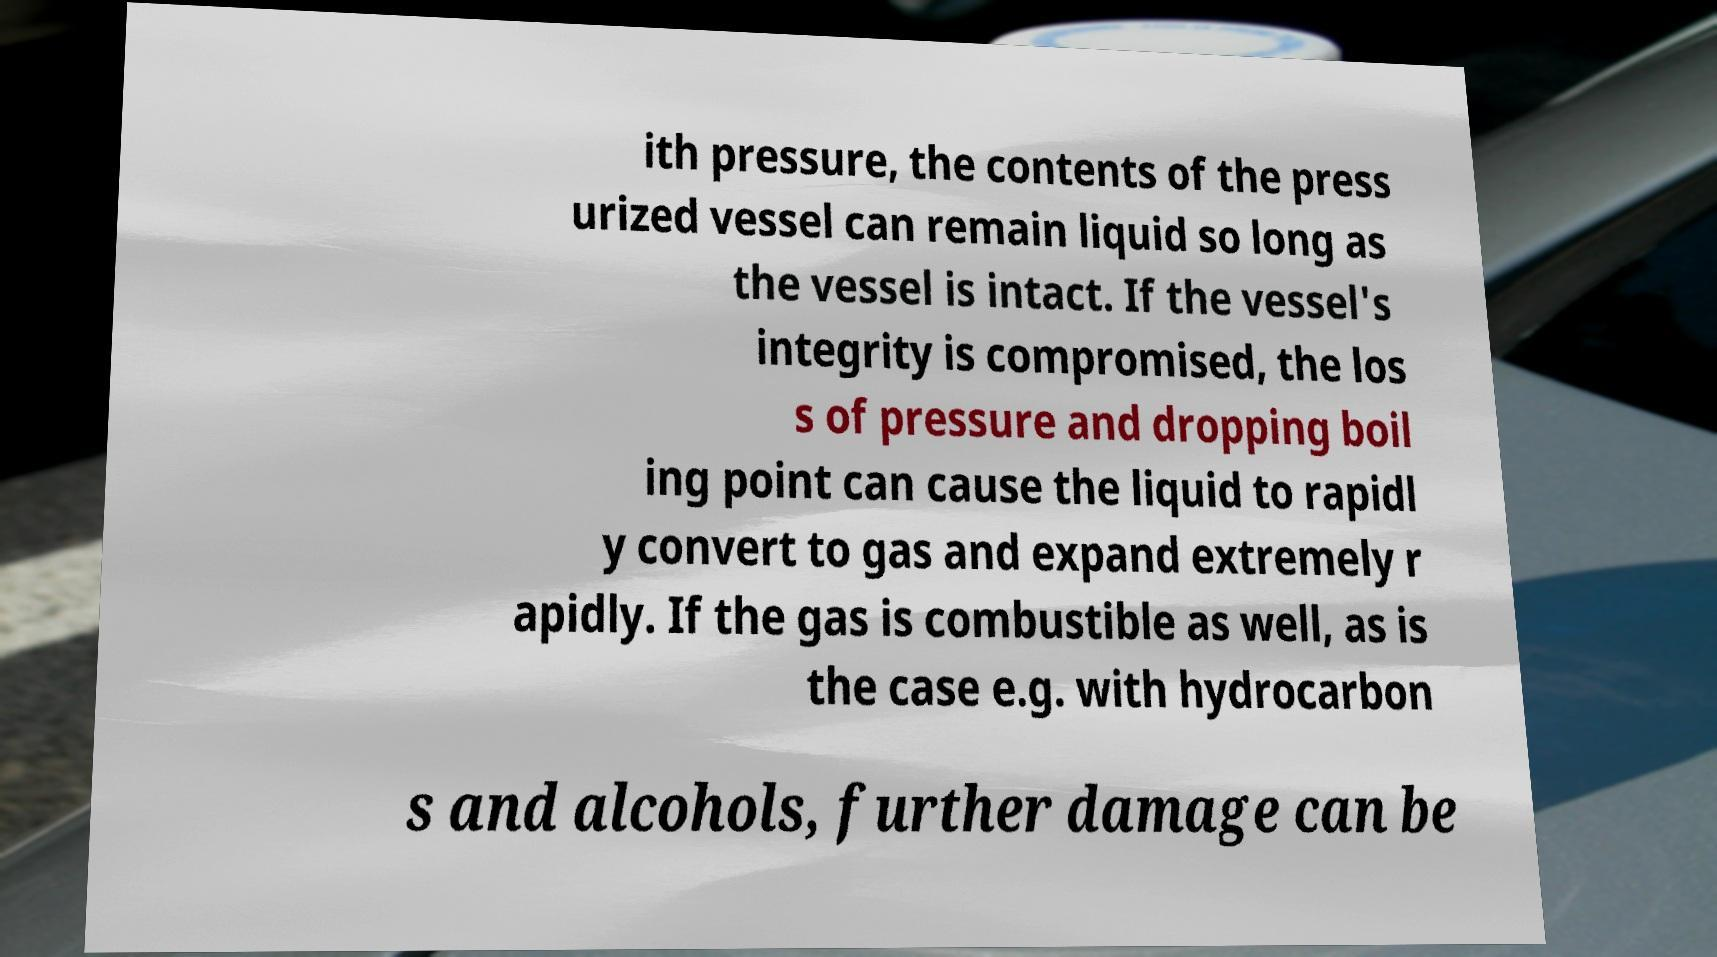Please read and relay the text visible in this image. What does it say? ith pressure, the contents of the press urized vessel can remain liquid so long as the vessel is intact. If the vessel's integrity is compromised, the los s of pressure and dropping boil ing point can cause the liquid to rapidl y convert to gas and expand extremely r apidly. If the gas is combustible as well, as is the case e.g. with hydrocarbon s and alcohols, further damage can be 